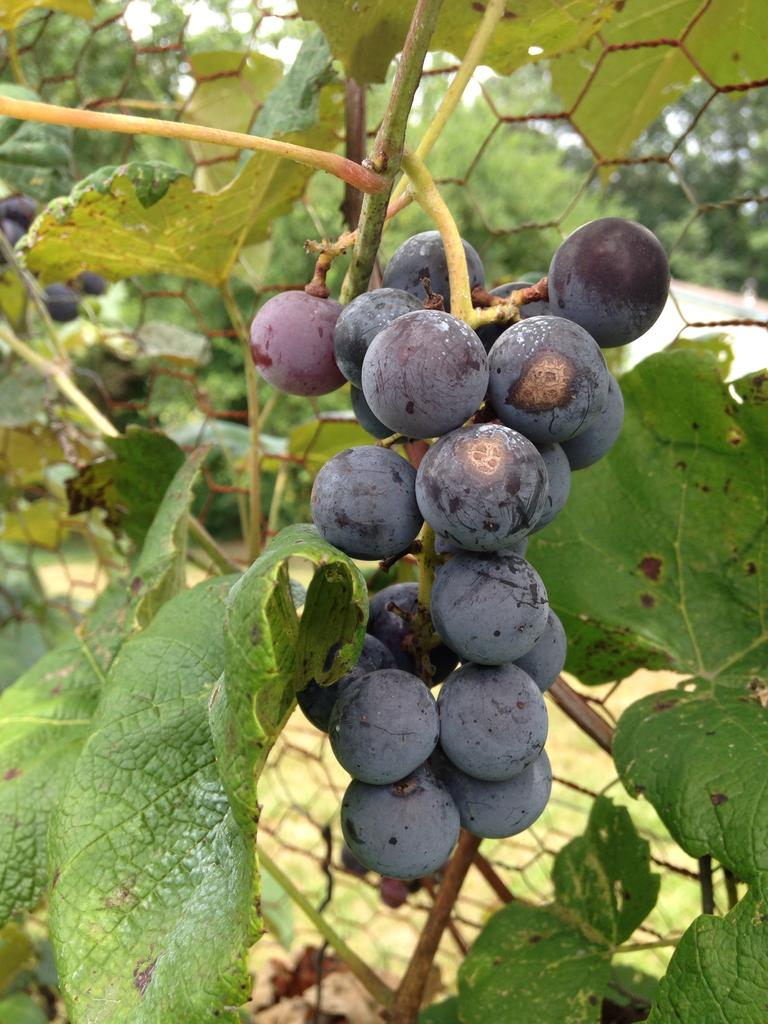What type of tree is in the picture? There is a grape tree in the picture. What is the material of the fence in the picture? The fence in the picture is made of metal. How does the grape tree help the island in the picture? There is no island present in the picture, and the grape tree is not helping any island. 